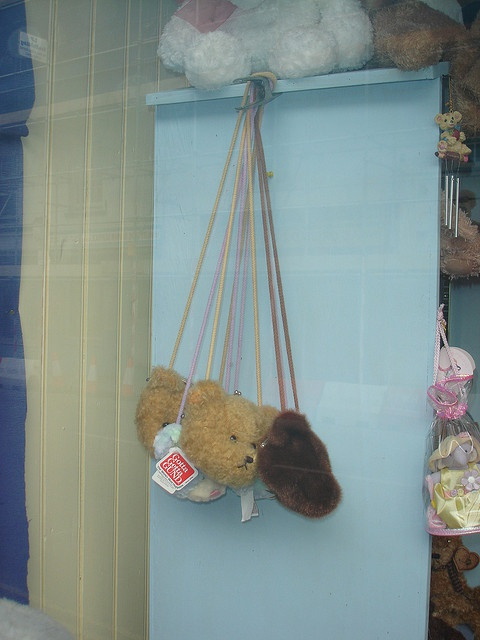Describe the objects in this image and their specific colors. I can see teddy bear in gray and darkgray tones, teddy bear in gray, tan, olive, and darkgray tones, teddy bear in gray and black tones, and teddy bear in gray, black, and maroon tones in this image. 